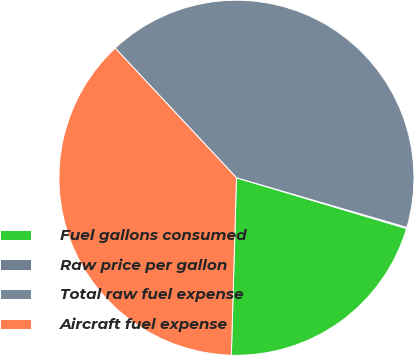Convert chart. <chart><loc_0><loc_0><loc_500><loc_500><pie_chart><fcel>Fuel gallons consumed<fcel>Raw price per gallon<fcel>Total raw fuel expense<fcel>Aircraft fuel expense<nl><fcel>20.84%<fcel>0.11%<fcel>41.48%<fcel>37.57%<nl></chart> 